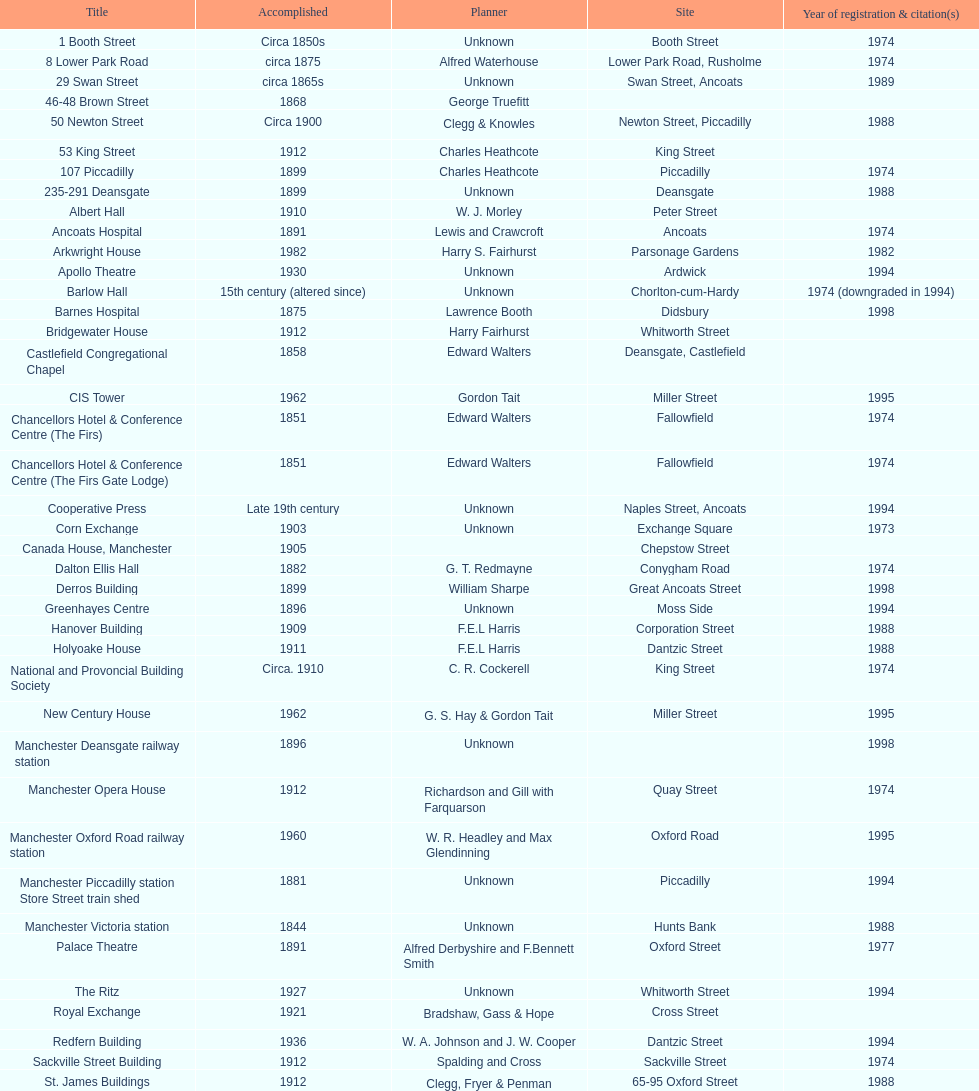How many names are listed with an image? 39. 